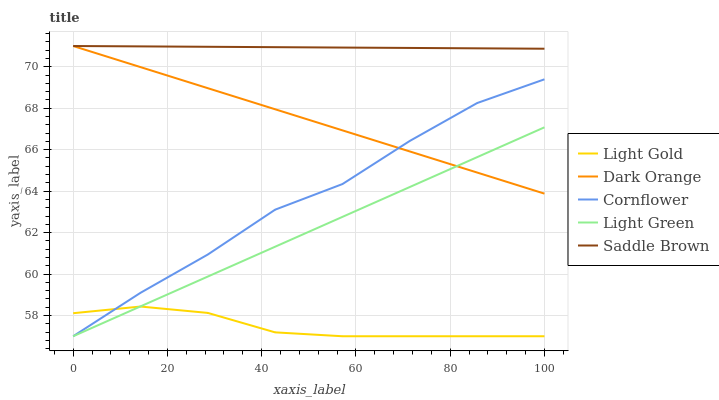Does Light Gold have the minimum area under the curve?
Answer yes or no. Yes. Does Saddle Brown have the maximum area under the curve?
Answer yes or no. Yes. Does Saddle Brown have the minimum area under the curve?
Answer yes or no. No. Does Light Gold have the maximum area under the curve?
Answer yes or no. No. Is Saddle Brown the smoothest?
Answer yes or no. Yes. Is Cornflower the roughest?
Answer yes or no. Yes. Is Light Gold the smoothest?
Answer yes or no. No. Is Light Gold the roughest?
Answer yes or no. No. Does Saddle Brown have the lowest value?
Answer yes or no. No. Does Saddle Brown have the highest value?
Answer yes or no. Yes. Does Light Gold have the highest value?
Answer yes or no. No. Is Cornflower less than Saddle Brown?
Answer yes or no. Yes. Is Dark Orange greater than Light Gold?
Answer yes or no. Yes. Does Light Green intersect Light Gold?
Answer yes or no. Yes. Is Light Green less than Light Gold?
Answer yes or no. No. Is Light Green greater than Light Gold?
Answer yes or no. No. Does Cornflower intersect Saddle Brown?
Answer yes or no. No. 